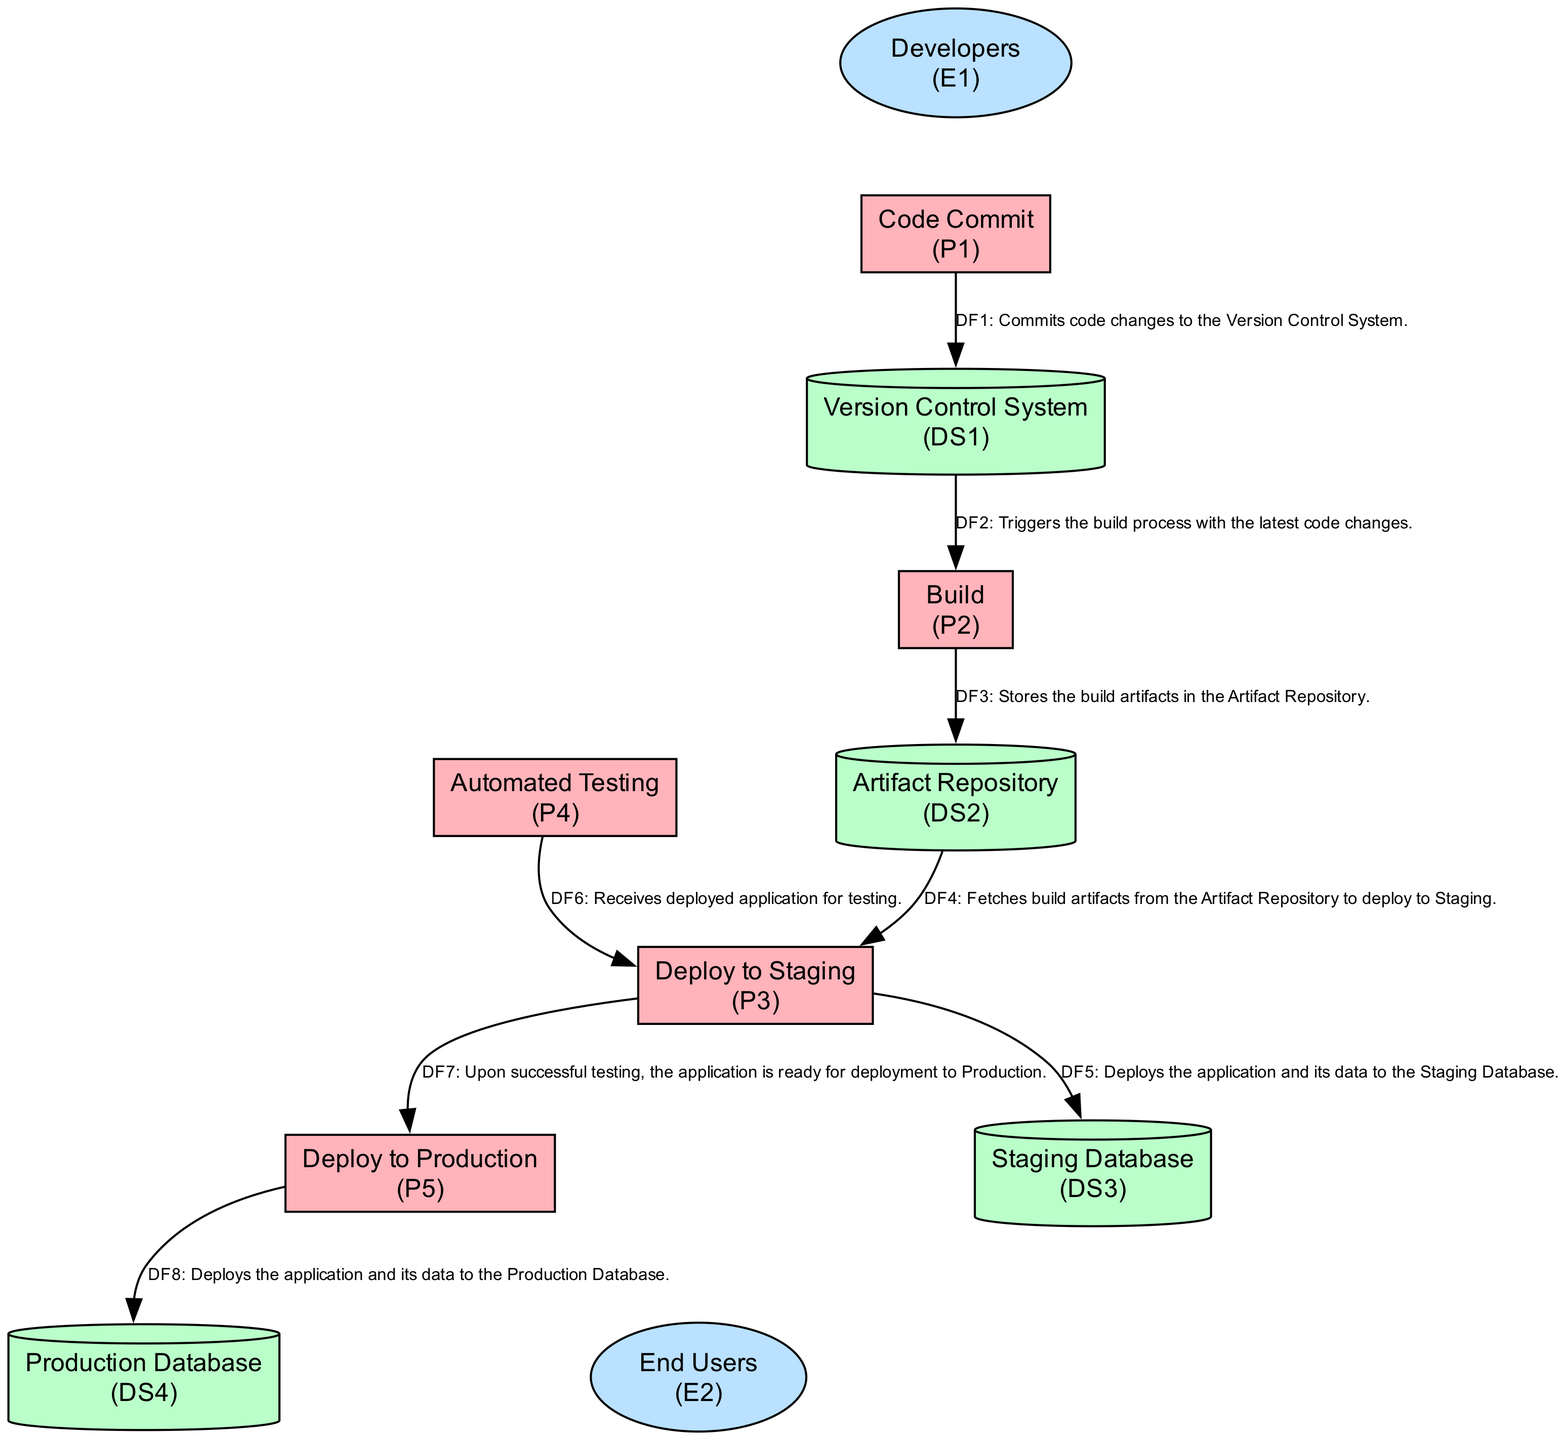What is the first process in the CI/CD pipeline? The first process listed in the diagram is "Code Commit" (P1), where developers commit code changes.
Answer: Code Commit How many processes are there in the CI/CD pipeline? By counting the listed processes in the diagram, there are five processes (P1 to P5).
Answer: Five Which data store does the "Build" process send its artifacts to? The "Build" process (P2) sends its artifacts to the "Artifact Repository" (DS2), as indicated by the data flow from P2 to DS2.
Answer: Artifact Repository What do developers do as an external entity in the CI/CD pipeline? The external entity "Developers" commits code changes to the "Version Control System," which is indicated by the data flow from E1 to P1.
Answer: Commit code changes What happens after successful testing in the CI/CD pipeline? Following successful testing in the "Automated Testing" process (P4), the application is ready for deployment to Production (P5). This is indicated by the flow from P4 to P3 and then from P3 to P5.
Answer: Deploy to Production Which data store is linked to the production environment? The data store related to the production environment is the "Production Database" (DS4) as indicated by the flow from P5 to DS4.
Answer: Production Database What is the purpose of the "Deploy to Staging" process? The "Deploy to Staging" process (P3) deploys the built application to the staging environment for further testing, as described in the process.
Answer: Deploy built application How many data stores are in the CI/CD pipeline? There are four data stores listed in the diagram: "Version Control System," "Artifact Repository," "Staging Database," and "Production Database."
Answer: Four Which external entity receives the deployed application in the production environment? The external entity that receives the deployed application in the production environment is "End Users" (E2), as shown by the flow from P5 to E2.
Answer: End Users What type of testing is conducted in the staging environment? The "Automated Testing" process (P4) conducts automated integration and system tests on the staging environment, as defined in its description.
Answer: Automated Testing 